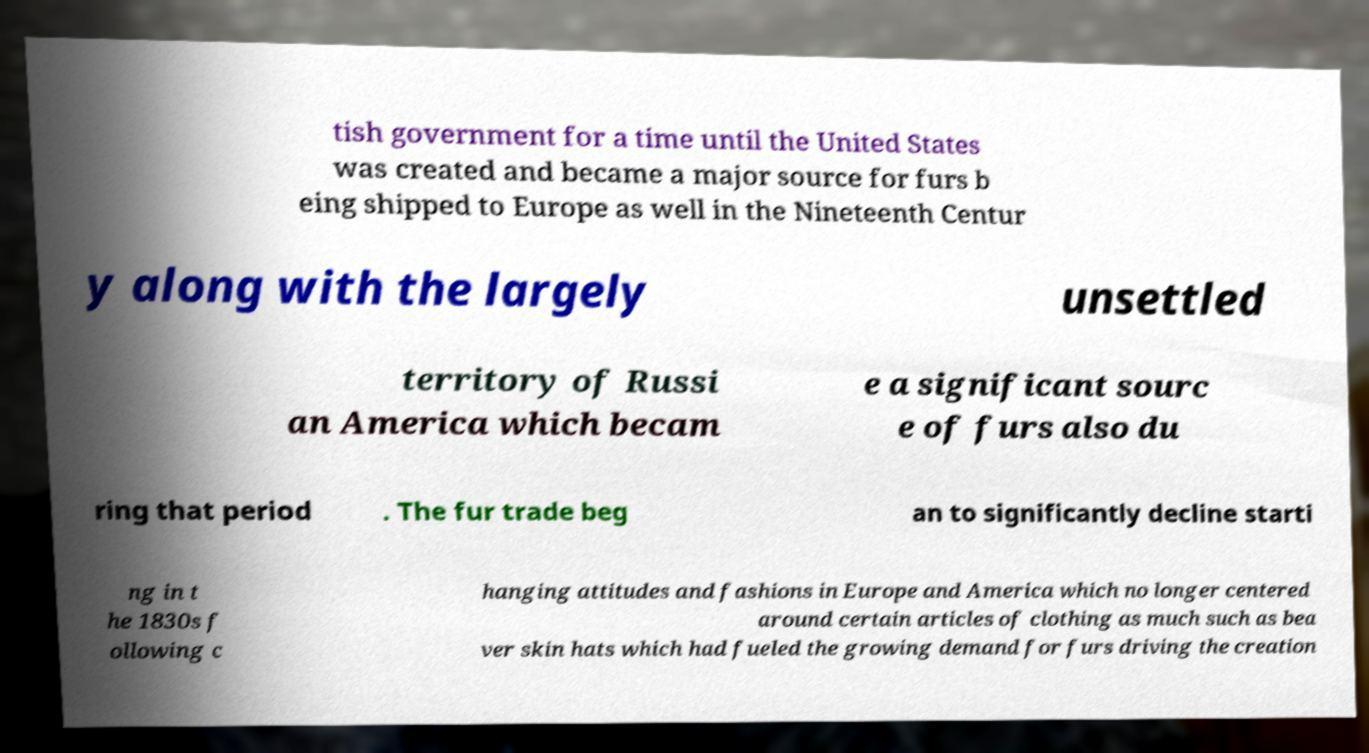There's text embedded in this image that I need extracted. Can you transcribe it verbatim? tish government for a time until the United States was created and became a major source for furs b eing shipped to Europe as well in the Nineteenth Centur y along with the largely unsettled territory of Russi an America which becam e a significant sourc e of furs also du ring that period . The fur trade beg an to significantly decline starti ng in t he 1830s f ollowing c hanging attitudes and fashions in Europe and America which no longer centered around certain articles of clothing as much such as bea ver skin hats which had fueled the growing demand for furs driving the creation 